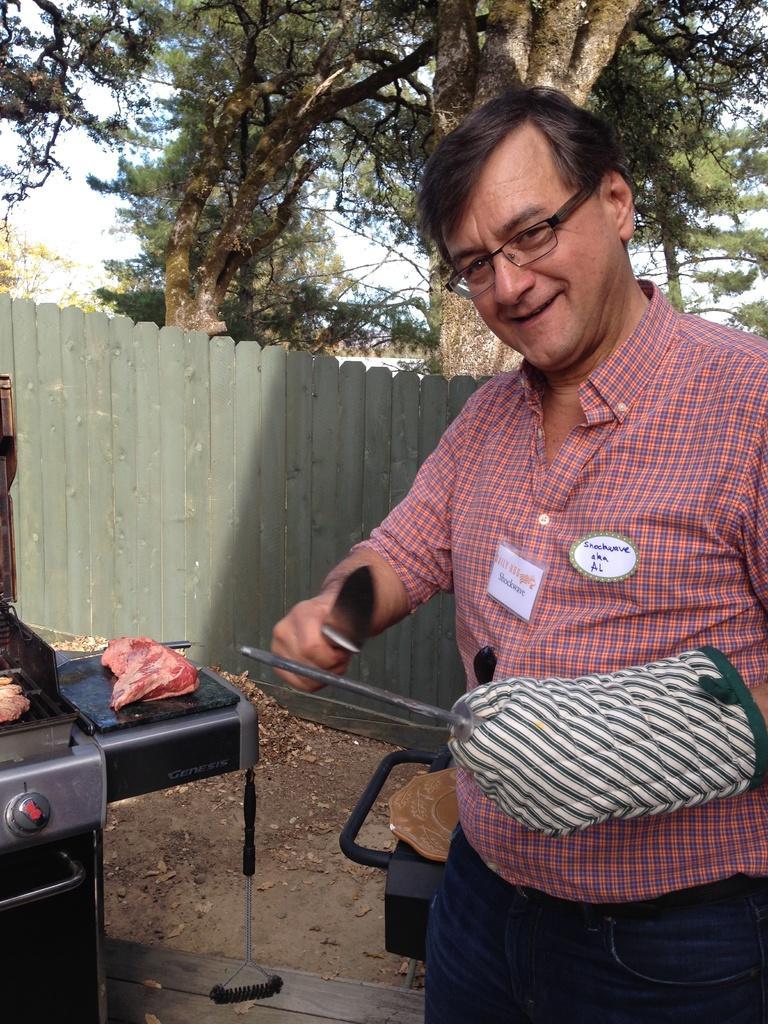How would you summarize this image in a sentence or two? In the image there is a man with shirt and glove to his hand is standing and holding a knife and another object in the hand. He is smiling and he kept spectacles. Behind him there is a black object. On the left side of the image there is a stove with grill. Beside the stove there is a table with meat. Behind them there is a wooden fencing and on the ground there are dry leaves. In the background there are trees.  